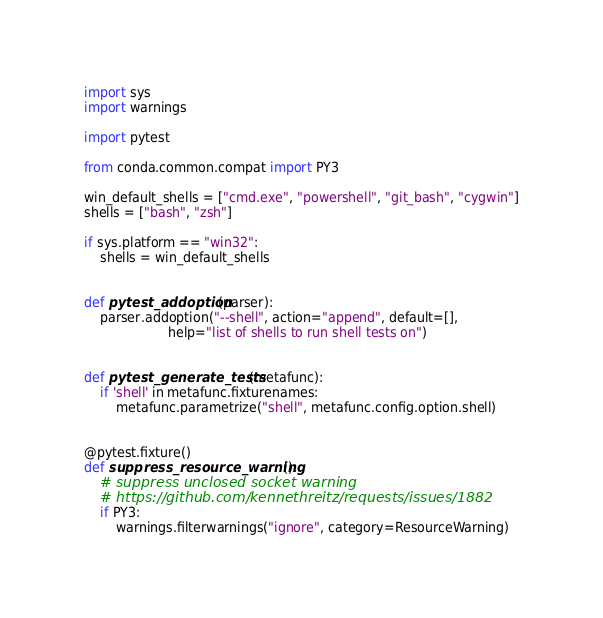Convert code to text. <code><loc_0><loc_0><loc_500><loc_500><_Python_>import sys
import warnings

import pytest

from conda.common.compat import PY3

win_default_shells = ["cmd.exe", "powershell", "git_bash", "cygwin"]
shells = ["bash", "zsh"]

if sys.platform == "win32":
    shells = win_default_shells


def pytest_addoption(parser):
    parser.addoption("--shell", action="append", default=[],
                     help="list of shells to run shell tests on")


def pytest_generate_tests(metafunc):
    if 'shell' in metafunc.fixturenames:
        metafunc.parametrize("shell", metafunc.config.option.shell)


@pytest.fixture()
def suppress_resource_warning():
    # suppress unclosed socket warning
    # https://github.com/kennethreitz/requests/issues/1882
    if PY3:
        warnings.filterwarnings("ignore", category=ResourceWarning)
</code> 